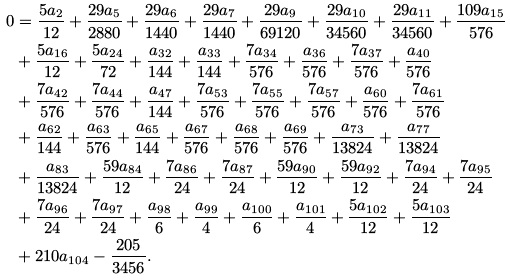Convert formula to latex. <formula><loc_0><loc_0><loc_500><loc_500>0 & = \frac { 5 a _ { 2 } } { 1 2 } + \frac { 2 9 a _ { 5 } } { 2 8 8 0 } + \frac { 2 9 a _ { 6 } } { 1 4 4 0 } + \frac { 2 9 a _ { 7 } } { 1 4 4 0 } + \frac { 2 9 a _ { 9 } } { 6 9 1 2 0 } + \frac { 2 9 a _ { 1 0 } } { 3 4 5 6 0 } + \frac { 2 9 a _ { 1 1 } } { 3 4 5 6 0 } + \frac { 1 0 9 a _ { 1 5 } } { 5 7 6 } \\ & + \frac { 5 a _ { 1 6 } } { 1 2 } + \frac { 5 a _ { 2 4 } } { 7 2 } + \frac { a _ { 3 2 } } { 1 4 4 } + \frac { a _ { 3 3 } } { 1 4 4 } + \frac { 7 a _ { 3 4 } } { 5 7 6 } + \frac { a _ { 3 6 } } { 5 7 6 } + \frac { 7 a _ { 3 7 } } { 5 7 6 } + \frac { a _ { 4 0 } } { 5 7 6 } \\ & + \frac { 7 a _ { 4 2 } } { 5 7 6 } + \frac { 7 a _ { 4 4 } } { 5 7 6 } + \frac { a _ { 4 7 } } { 1 4 4 } + \frac { 7 a _ { 5 3 } } { 5 7 6 } + \frac { 7 a _ { 5 5 } } { 5 7 6 } + \frac { 7 a _ { 5 7 } } { 5 7 6 } + \frac { a _ { 6 0 } } { 5 7 6 } + \frac { 7 a _ { 6 1 } } { 5 7 6 } \\ & + \frac { a _ { 6 2 } } { 1 4 4 } + \frac { a _ { 6 3 } } { 5 7 6 } + \frac { a _ { 6 5 } } { 1 4 4 } + \frac { a _ { 6 7 } } { 5 7 6 } + \frac { a _ { 6 8 } } { 5 7 6 } + \frac { a _ { 6 9 } } { 5 7 6 } + \frac { a _ { 7 3 } } { 1 3 8 2 4 } + \frac { a _ { 7 7 } } { 1 3 8 2 4 } \\ & + \frac { a _ { 8 3 } } { 1 3 8 2 4 } + \frac { 5 9 a _ { 8 4 } } { 1 2 } + \frac { 7 a _ { 8 6 } } { 2 4 } + \frac { 7 a _ { 8 7 } } { 2 4 } + \frac { 5 9 a _ { 9 0 } } { 1 2 } + \frac { 5 9 a _ { 9 2 } } { 1 2 } + \frac { 7 a _ { 9 4 } } { 2 4 } + \frac { 7 a _ { 9 5 } } { 2 4 } \\ & + \frac { 7 a _ { 9 6 } } { 2 4 } + \frac { 7 a _ { 9 7 } } { 2 4 } + \frac { a _ { 9 8 } } { 6 } + \frac { a _ { 9 9 } } { 4 } + \frac { a _ { 1 0 0 } } { 6 } + \frac { a _ { 1 0 1 } } { 4 } + \frac { 5 a _ { 1 0 2 } } { 1 2 } + \frac { 5 a _ { 1 0 3 } } { 1 2 } \\ & + 2 1 0 a _ { 1 0 4 } - \frac { 2 0 5 } { 3 4 5 6 } .</formula> 